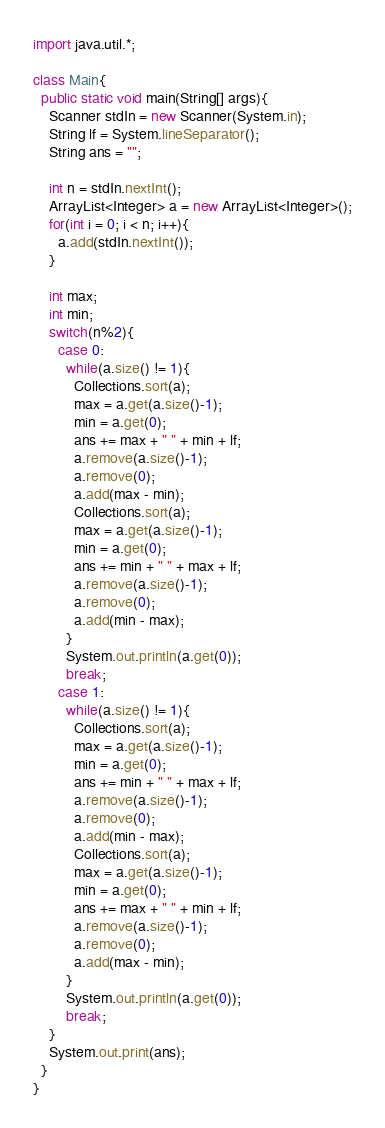<code> <loc_0><loc_0><loc_500><loc_500><_Java_>import java.util.*;

class Main{
  public static void main(String[] args){
    Scanner stdIn = new Scanner(System.in);
    String lf = System.lineSeparator();
    String ans = "";
    
    int n = stdIn.nextInt();
    ArrayList<Integer> a = new ArrayList<Integer>();
    for(int i = 0; i < n; i++){
      a.add(stdIn.nextInt());
    }
    
    int max;
    int min;
    switch(n%2){
      case 0:
        while(a.size() != 1){
          Collections.sort(a);
          max = a.get(a.size()-1);
          min = a.get(0);
          ans += max + " " + min + lf;
          a.remove(a.size()-1);
          a.remove(0);
          a.add(max - min);
          Collections.sort(a);
          max = a.get(a.size()-1);
          min = a.get(0);
          ans += min + " " + max + lf;
          a.remove(a.size()-1);
          a.remove(0);
          a.add(min - max);
        }
        System.out.println(a.get(0));
        break;
      case 1:
        while(a.size() != 1){
          Collections.sort(a);
          max = a.get(a.size()-1);
          min = a.get(0);
          ans += min + " " + max + lf;
          a.remove(a.size()-1);
          a.remove(0);
          a.add(min - max);
          Collections.sort(a);
          max = a.get(a.size()-1);
          min = a.get(0);
          ans += max + " " + min + lf;
          a.remove(a.size()-1);
          a.remove(0);
          a.add(max - min);
        }
        System.out.println(a.get(0));
        break;
    }
    System.out.print(ans);
  }
}
</code> 